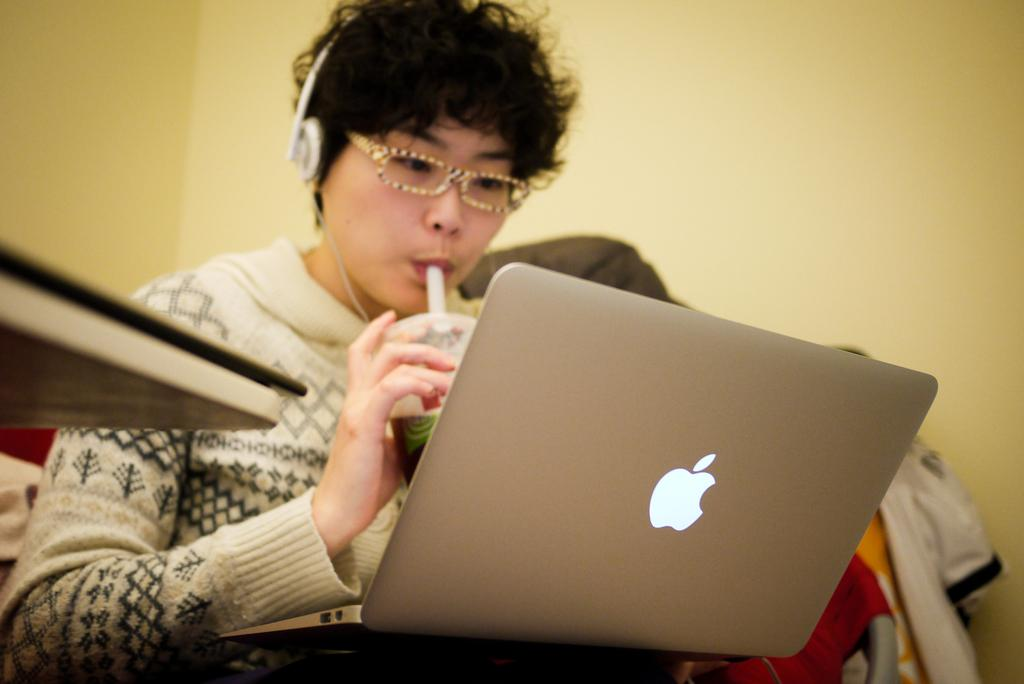What is the color of the wall in the image? The wall in the image is yellow. What piece of furniture is present in the image? There is a table in the image. What type of material is visible in the image? There are cloths in the image. Who is present in the image? There is a woman in the image. What is the woman wearing? The woman is wearing a white color jacket and spectacles. What object is the woman holding? The woman is holding a glass. What electronic device is visible in the image? There is a laptop in the front of the image. How many fairies are flying around the laptop in the image? There are no fairies present in the image; it only features a woman, a table, a yellow wall, cloths, a glass, and a laptop. 